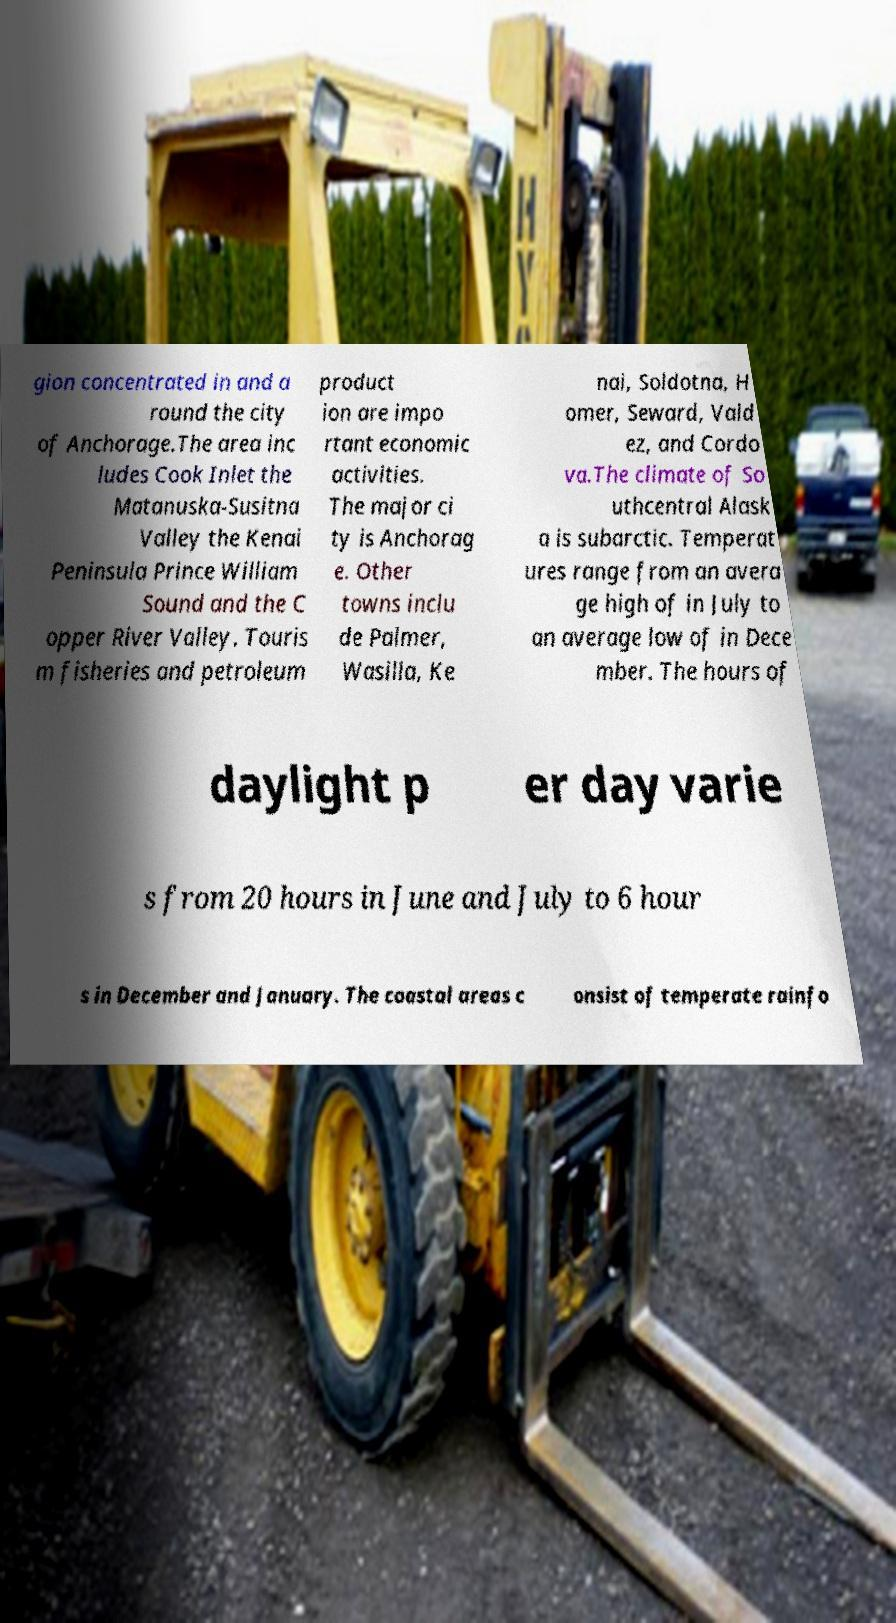Can you accurately transcribe the text from the provided image for me? gion concentrated in and a round the city of Anchorage.The area inc ludes Cook Inlet the Matanuska-Susitna Valley the Kenai Peninsula Prince William Sound and the C opper River Valley. Touris m fisheries and petroleum product ion are impo rtant economic activities. The major ci ty is Anchorag e. Other towns inclu de Palmer, Wasilla, Ke nai, Soldotna, H omer, Seward, Vald ez, and Cordo va.The climate of So uthcentral Alask a is subarctic. Temperat ures range from an avera ge high of in July to an average low of in Dece mber. The hours of daylight p er day varie s from 20 hours in June and July to 6 hour s in December and January. The coastal areas c onsist of temperate rainfo 